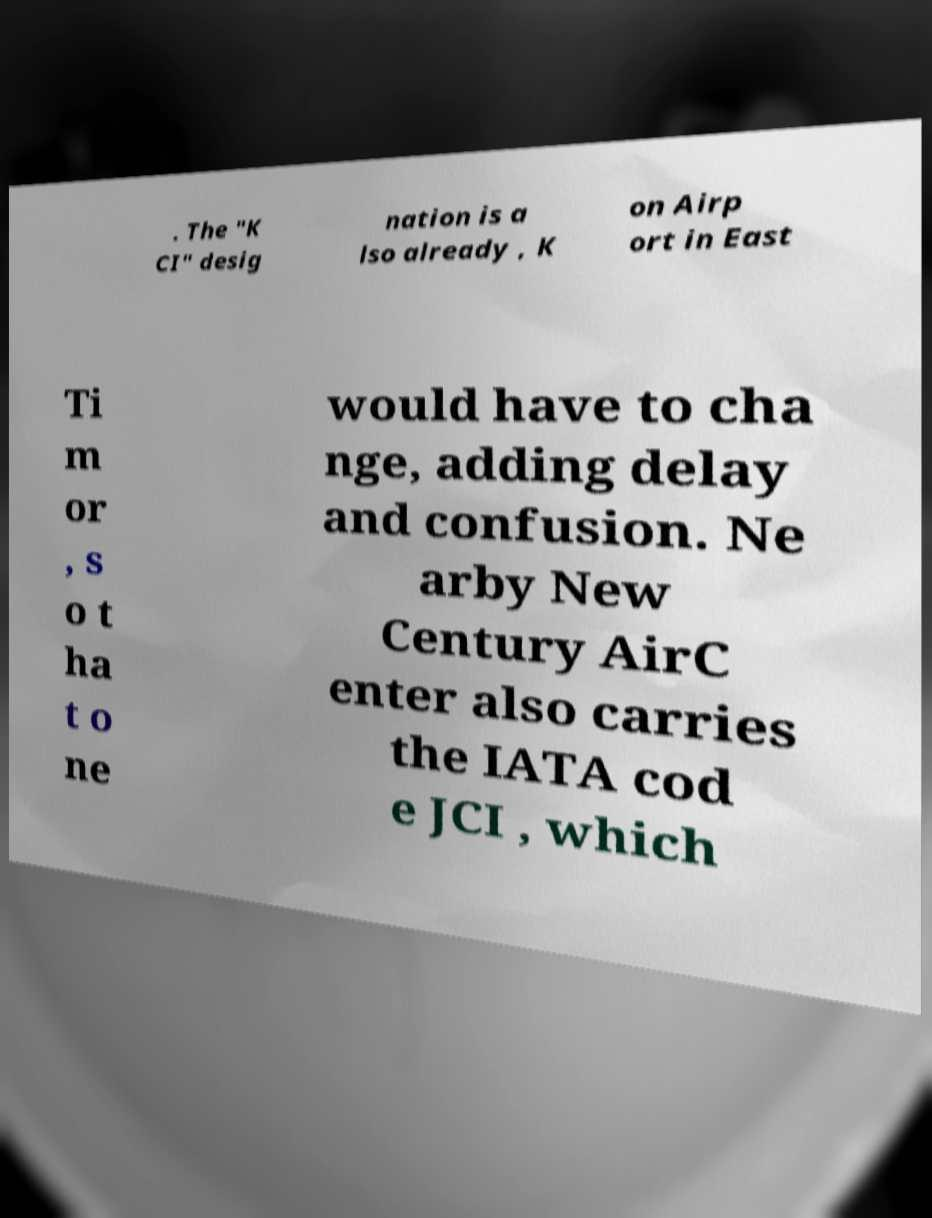Can you read and provide the text displayed in the image?This photo seems to have some interesting text. Can you extract and type it out for me? . The "K CI" desig nation is a lso already , K on Airp ort in East Ti m or , s o t ha t o ne would have to cha nge, adding delay and confusion. Ne arby New Century AirC enter also carries the IATA cod e JCI , which 